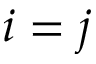Convert formula to latex. <formula><loc_0><loc_0><loc_500><loc_500>i = j</formula> 